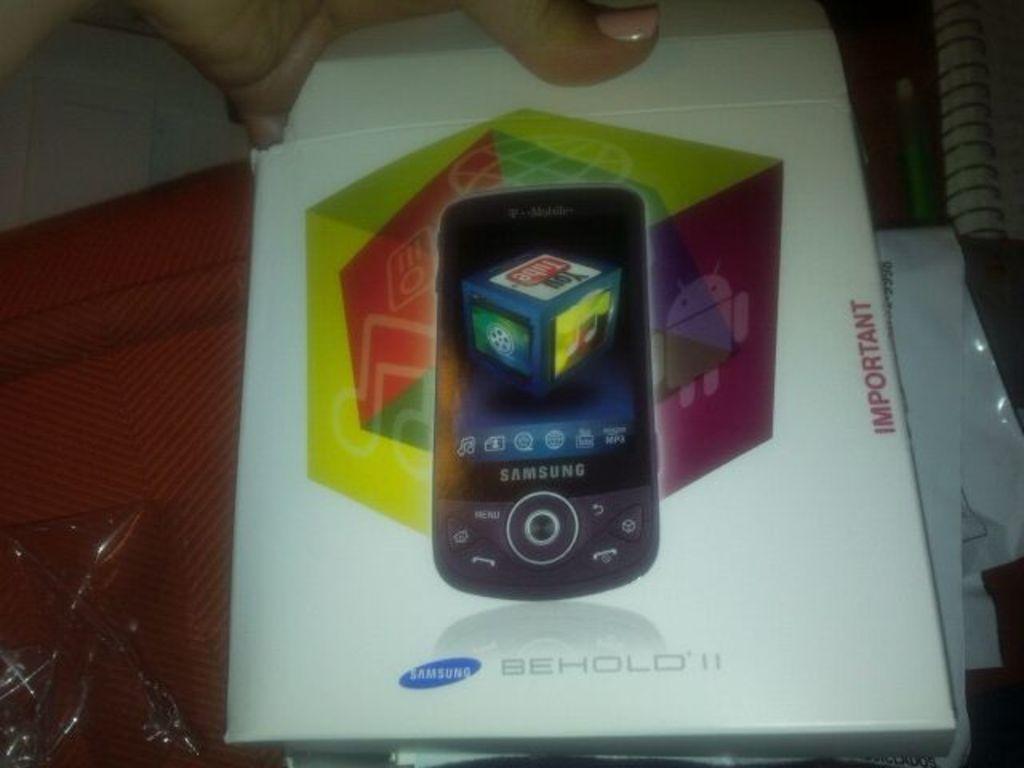What brand is the phone?
Provide a short and direct response. Samsung. What kind of phone is this?
Make the answer very short. Samsung. 